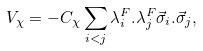Convert formula to latex. <formula><loc_0><loc_0><loc_500><loc_500>V _ { \chi } = - C _ { \chi } \sum _ { i < j } \lambda _ { i } ^ { F } . \lambda _ { j } ^ { F } \vec { \sigma } _ { i } . \vec { \sigma } _ { j } ,</formula> 